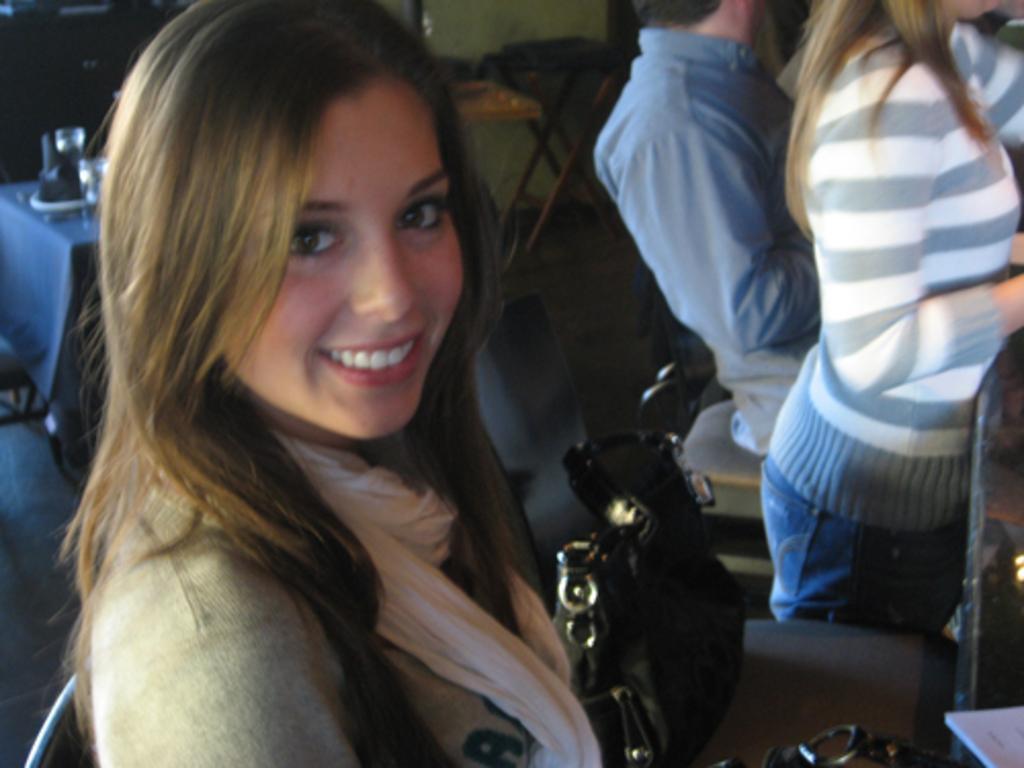Describe this image in one or two sentences. In the foreground there is a woman smiling. In the center there is a bag. On the right there are people and other objects. At the top there are chairs, table, glasses and other objects. 